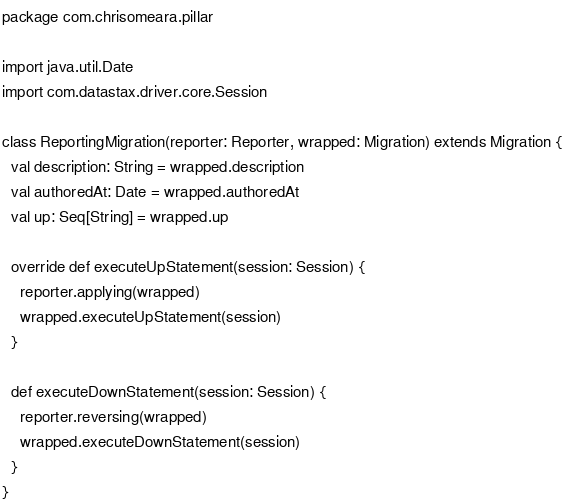<code> <loc_0><loc_0><loc_500><loc_500><_Scala_>package com.chrisomeara.pillar

import java.util.Date
import com.datastax.driver.core.Session

class ReportingMigration(reporter: Reporter, wrapped: Migration) extends Migration {
  val description: String = wrapped.description
  val authoredAt: Date = wrapped.authoredAt
  val up: Seq[String] = wrapped.up

  override def executeUpStatement(session: Session) {
    reporter.applying(wrapped)
    wrapped.executeUpStatement(session)
  }

  def executeDownStatement(session: Session) {
    reporter.reversing(wrapped)
    wrapped.executeDownStatement(session)
  }
}</code> 